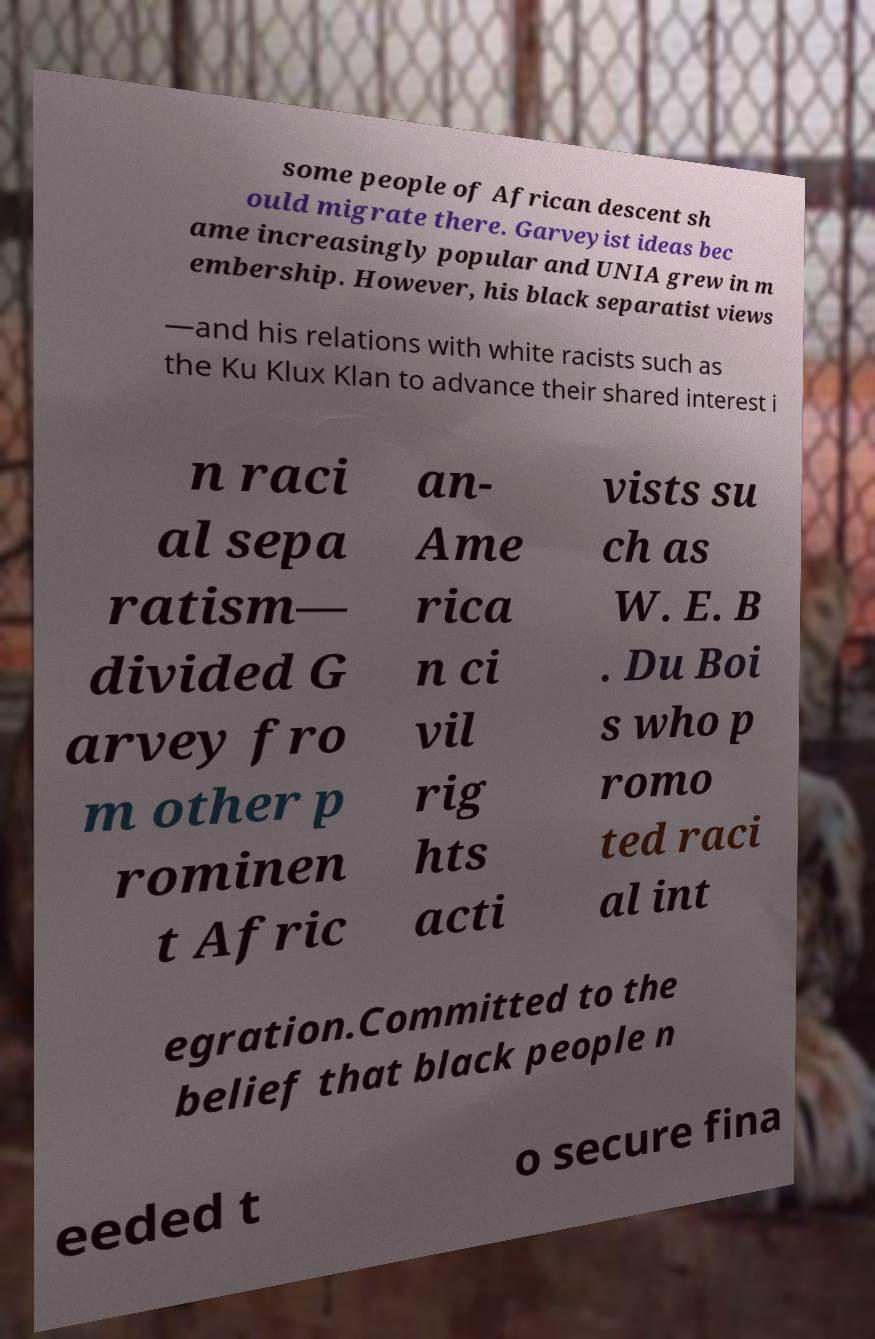What messages or text are displayed in this image? I need them in a readable, typed format. some people of African descent sh ould migrate there. Garveyist ideas bec ame increasingly popular and UNIA grew in m embership. However, his black separatist views —and his relations with white racists such as the Ku Klux Klan to advance their shared interest i n raci al sepa ratism— divided G arvey fro m other p rominen t Afric an- Ame rica n ci vil rig hts acti vists su ch as W. E. B . Du Boi s who p romo ted raci al int egration.Committed to the belief that black people n eeded t o secure fina 